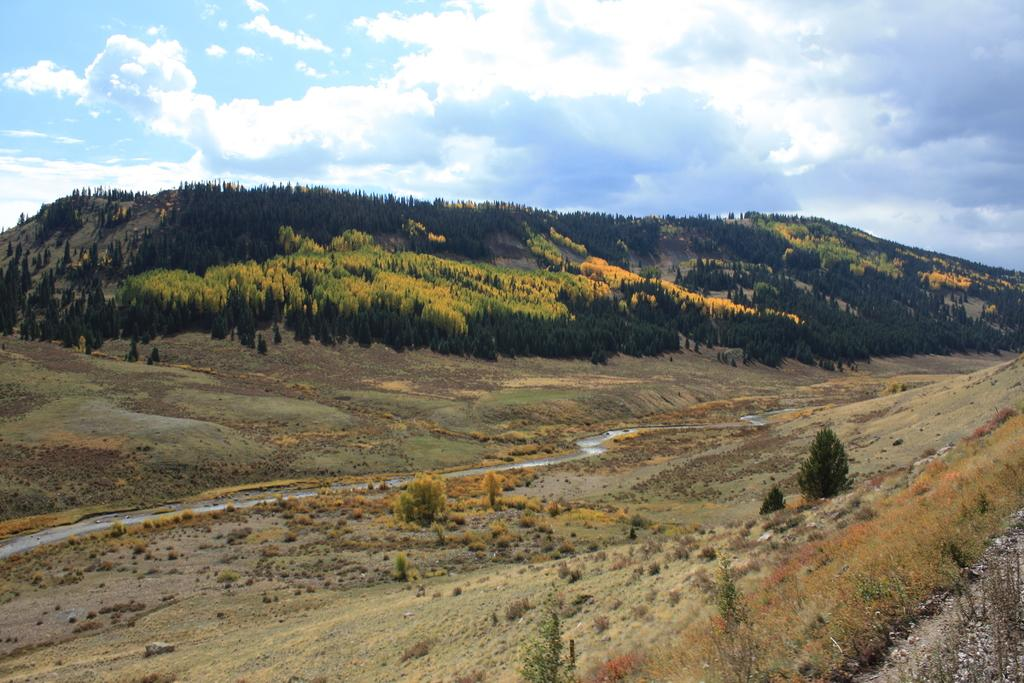What type of vegetation can be seen in the image? There are plants and trees in the image. What kind of path is present in the image? There is a walkway in the image. What is visible in the background of the image? There is a mountain in the background of the image. What can be seen on the mountain in the image? The mountain has trees on it. What is visible at the top of the image? The sky is visible at the top of the image. How many toes are visible on the plants in the image? Plants do not have toes, so none are visible in the image. What is the value of the trees in the image? The value of the trees cannot be determined from the image alone, as it is a subjective concept. 